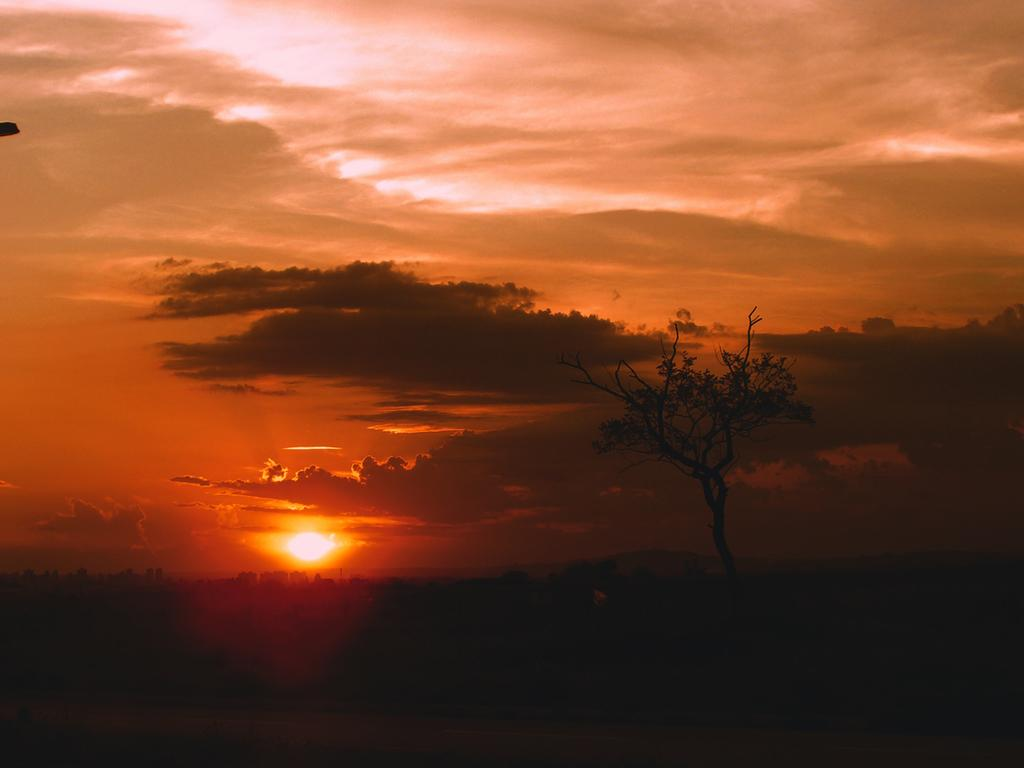What type of vegetation is at the bottom of the image? There are trees at the bottom of the image. What is visible at the top of the image? The sky is visible at the top of the image. What is the weather like in the image? The sky is cloudy, suggesting a partly cloudy or overcast day. Can you describe the sun in the image? Yes, there is a sun in the middle of the image. What type of mint plant can be seen growing on the sun in the image? There is no mint plant present in the image, and the sun is not a suitable location for plant growth. What color is the vest worn by the sky in the image? The sky is not a person or object that can wear a vest; it is a natural phenomenon. 